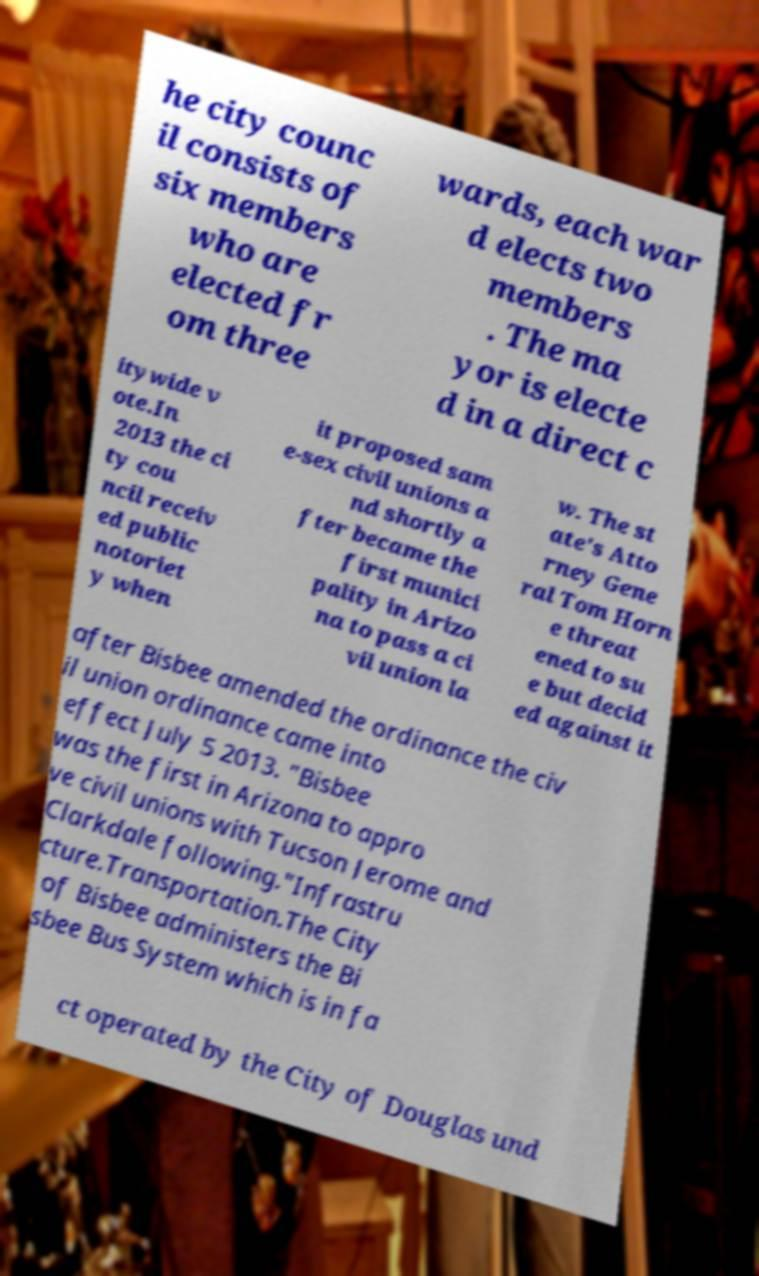For documentation purposes, I need the text within this image transcribed. Could you provide that? he city counc il consists of six members who are elected fr om three wards, each war d elects two members . The ma yor is electe d in a direct c itywide v ote.In 2013 the ci ty cou ncil receiv ed public notoriet y when it proposed sam e-sex civil unions a nd shortly a fter became the first munici pality in Arizo na to pass a ci vil union la w. The st ate's Atto rney Gene ral Tom Horn e threat ened to su e but decid ed against it after Bisbee amended the ordinance the civ il union ordinance came into effect July 5 2013. "Bisbee was the first in Arizona to appro ve civil unions with Tucson Jerome and Clarkdale following."Infrastru cture.Transportation.The City of Bisbee administers the Bi sbee Bus System which is in fa ct operated by the City of Douglas und 